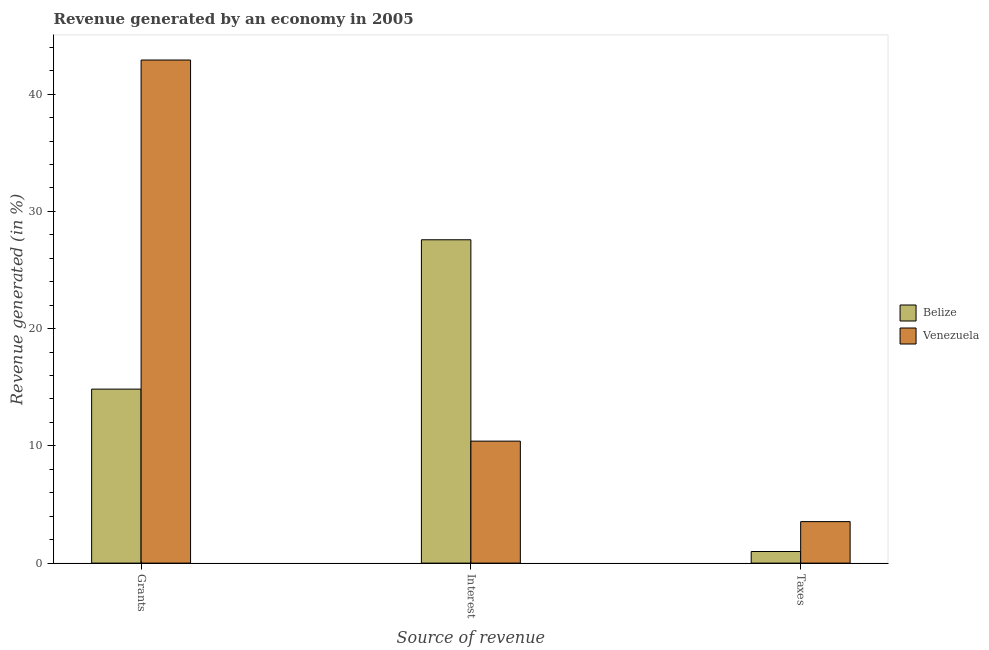How many different coloured bars are there?
Make the answer very short. 2. How many groups of bars are there?
Make the answer very short. 3. Are the number of bars per tick equal to the number of legend labels?
Your response must be concise. Yes. Are the number of bars on each tick of the X-axis equal?
Your response must be concise. Yes. How many bars are there on the 3rd tick from the left?
Your answer should be very brief. 2. How many bars are there on the 3rd tick from the right?
Ensure brevity in your answer.  2. What is the label of the 3rd group of bars from the left?
Offer a very short reply. Taxes. What is the percentage of revenue generated by grants in Venezuela?
Give a very brief answer. 42.91. Across all countries, what is the maximum percentage of revenue generated by interest?
Ensure brevity in your answer.  27.58. Across all countries, what is the minimum percentage of revenue generated by grants?
Offer a terse response. 14.84. In which country was the percentage of revenue generated by grants maximum?
Give a very brief answer. Venezuela. In which country was the percentage of revenue generated by grants minimum?
Offer a very short reply. Belize. What is the total percentage of revenue generated by interest in the graph?
Your answer should be very brief. 37.98. What is the difference between the percentage of revenue generated by grants in Belize and that in Venezuela?
Your response must be concise. -28.07. What is the difference between the percentage of revenue generated by interest in Venezuela and the percentage of revenue generated by grants in Belize?
Provide a succinct answer. -4.44. What is the average percentage of revenue generated by interest per country?
Offer a terse response. 18.99. What is the difference between the percentage of revenue generated by interest and percentage of revenue generated by grants in Belize?
Your answer should be very brief. 12.74. What is the ratio of the percentage of revenue generated by grants in Venezuela to that in Belize?
Provide a short and direct response. 2.89. Is the difference between the percentage of revenue generated by taxes in Belize and Venezuela greater than the difference between the percentage of revenue generated by grants in Belize and Venezuela?
Your answer should be compact. Yes. What is the difference between the highest and the second highest percentage of revenue generated by interest?
Keep it short and to the point. 17.17. What is the difference between the highest and the lowest percentage of revenue generated by interest?
Provide a short and direct response. 17.17. In how many countries, is the percentage of revenue generated by taxes greater than the average percentage of revenue generated by taxes taken over all countries?
Provide a succinct answer. 1. What does the 1st bar from the left in Taxes represents?
Give a very brief answer. Belize. What does the 1st bar from the right in Taxes represents?
Keep it short and to the point. Venezuela. How many bars are there?
Keep it short and to the point. 6. Are all the bars in the graph horizontal?
Offer a terse response. No. What is the difference between two consecutive major ticks on the Y-axis?
Your response must be concise. 10. Are the values on the major ticks of Y-axis written in scientific E-notation?
Your answer should be compact. No. Does the graph contain grids?
Keep it short and to the point. No. How many legend labels are there?
Provide a short and direct response. 2. How are the legend labels stacked?
Your answer should be compact. Vertical. What is the title of the graph?
Provide a succinct answer. Revenue generated by an economy in 2005. Does "Monaco" appear as one of the legend labels in the graph?
Provide a succinct answer. No. What is the label or title of the X-axis?
Provide a short and direct response. Source of revenue. What is the label or title of the Y-axis?
Ensure brevity in your answer.  Revenue generated (in %). What is the Revenue generated (in %) in Belize in Grants?
Your answer should be compact. 14.84. What is the Revenue generated (in %) of Venezuela in Grants?
Make the answer very short. 42.91. What is the Revenue generated (in %) in Belize in Interest?
Make the answer very short. 27.58. What is the Revenue generated (in %) in Venezuela in Interest?
Offer a very short reply. 10.4. What is the Revenue generated (in %) of Belize in Taxes?
Keep it short and to the point. 0.99. What is the Revenue generated (in %) in Venezuela in Taxes?
Provide a short and direct response. 3.54. Across all Source of revenue, what is the maximum Revenue generated (in %) in Belize?
Keep it short and to the point. 27.58. Across all Source of revenue, what is the maximum Revenue generated (in %) of Venezuela?
Your response must be concise. 42.91. Across all Source of revenue, what is the minimum Revenue generated (in %) in Belize?
Make the answer very short. 0.99. Across all Source of revenue, what is the minimum Revenue generated (in %) in Venezuela?
Make the answer very short. 3.54. What is the total Revenue generated (in %) in Belize in the graph?
Provide a succinct answer. 43.41. What is the total Revenue generated (in %) of Venezuela in the graph?
Keep it short and to the point. 56.85. What is the difference between the Revenue generated (in %) in Belize in Grants and that in Interest?
Your response must be concise. -12.74. What is the difference between the Revenue generated (in %) of Venezuela in Grants and that in Interest?
Offer a terse response. 32.5. What is the difference between the Revenue generated (in %) of Belize in Grants and that in Taxes?
Your response must be concise. 13.85. What is the difference between the Revenue generated (in %) in Venezuela in Grants and that in Taxes?
Give a very brief answer. 39.37. What is the difference between the Revenue generated (in %) of Belize in Interest and that in Taxes?
Ensure brevity in your answer.  26.59. What is the difference between the Revenue generated (in %) in Venezuela in Interest and that in Taxes?
Provide a short and direct response. 6.86. What is the difference between the Revenue generated (in %) in Belize in Grants and the Revenue generated (in %) in Venezuela in Interest?
Your response must be concise. 4.44. What is the difference between the Revenue generated (in %) of Belize in Grants and the Revenue generated (in %) of Venezuela in Taxes?
Offer a terse response. 11.3. What is the difference between the Revenue generated (in %) in Belize in Interest and the Revenue generated (in %) in Venezuela in Taxes?
Your answer should be very brief. 24.04. What is the average Revenue generated (in %) in Belize per Source of revenue?
Give a very brief answer. 14.47. What is the average Revenue generated (in %) of Venezuela per Source of revenue?
Your answer should be compact. 18.95. What is the difference between the Revenue generated (in %) in Belize and Revenue generated (in %) in Venezuela in Grants?
Your answer should be compact. -28.07. What is the difference between the Revenue generated (in %) in Belize and Revenue generated (in %) in Venezuela in Interest?
Make the answer very short. 17.17. What is the difference between the Revenue generated (in %) of Belize and Revenue generated (in %) of Venezuela in Taxes?
Offer a terse response. -2.55. What is the ratio of the Revenue generated (in %) of Belize in Grants to that in Interest?
Keep it short and to the point. 0.54. What is the ratio of the Revenue generated (in %) of Venezuela in Grants to that in Interest?
Your response must be concise. 4.12. What is the ratio of the Revenue generated (in %) of Belize in Grants to that in Taxes?
Give a very brief answer. 14.99. What is the ratio of the Revenue generated (in %) of Venezuela in Grants to that in Taxes?
Provide a succinct answer. 12.12. What is the ratio of the Revenue generated (in %) in Belize in Interest to that in Taxes?
Offer a terse response. 27.86. What is the ratio of the Revenue generated (in %) in Venezuela in Interest to that in Taxes?
Give a very brief answer. 2.94. What is the difference between the highest and the second highest Revenue generated (in %) of Belize?
Your response must be concise. 12.74. What is the difference between the highest and the second highest Revenue generated (in %) in Venezuela?
Your answer should be very brief. 32.5. What is the difference between the highest and the lowest Revenue generated (in %) of Belize?
Offer a terse response. 26.59. What is the difference between the highest and the lowest Revenue generated (in %) of Venezuela?
Your answer should be very brief. 39.37. 